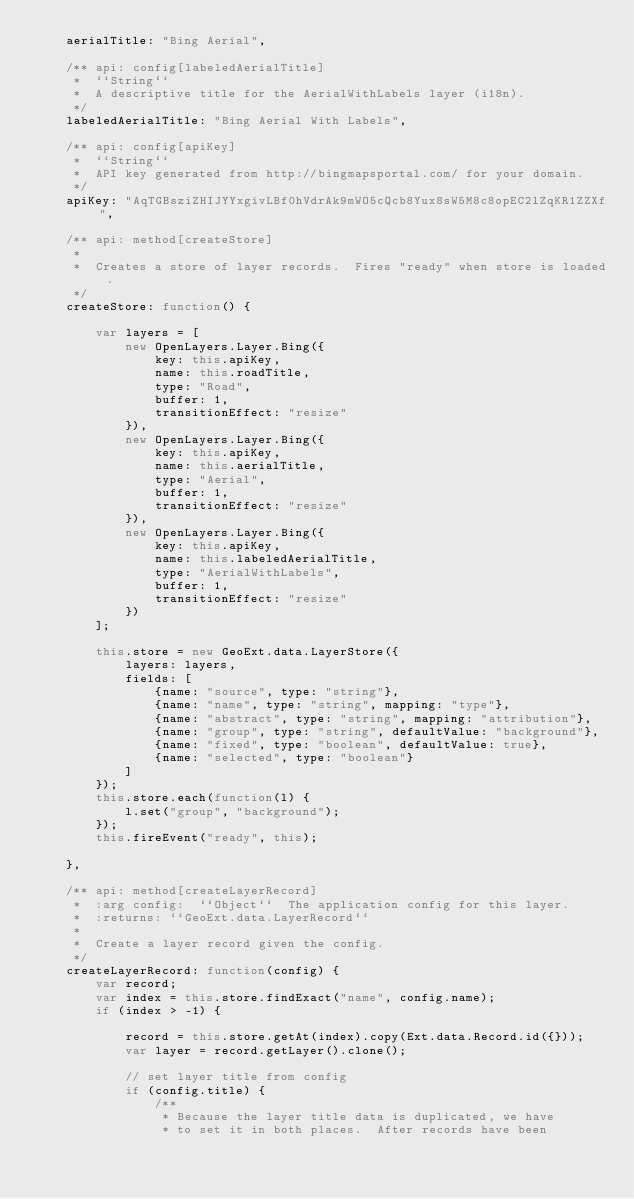Convert code to text. <code><loc_0><loc_0><loc_500><loc_500><_JavaScript_>    aerialTitle: "Bing Aerial",

    /** api: config[labeledAerialTitle]
     *  ``String``
     *  A descriptive title for the AerialWithLabels layer (i18n).
     */
    labeledAerialTitle: "Bing Aerial With Labels",
    
    /** api: config[apiKey]
     *  ``String``
     *  API key generated from http://bingmapsportal.com/ for your domain.
     */
    apiKey: "AqTGBsziZHIJYYxgivLBf0hVdrAk9mWO5cQcb8Yux8sW5M8c8opEC2lZqKR1ZZXf",
    
    /** api: method[createStore]
     *
     *  Creates a store of layer records.  Fires "ready" when store is loaded.
     */
    createStore: function() {
        
        var layers = [
            new OpenLayers.Layer.Bing({
                key: this.apiKey,
                name: this.roadTitle,
                type: "Road",
                buffer: 1,
                transitionEffect: "resize"
            }),
            new OpenLayers.Layer.Bing({
                key: this.apiKey,
                name: this.aerialTitle,
                type: "Aerial",
                buffer: 1,
                transitionEffect: "resize"
            }),
            new OpenLayers.Layer.Bing({
                key: this.apiKey,
                name: this.labeledAerialTitle,
                type: "AerialWithLabels",
                buffer: 1,
                transitionEffect: "resize"
            })
        ];
        
        this.store = new GeoExt.data.LayerStore({
            layers: layers,
            fields: [
                {name: "source", type: "string"},
                {name: "name", type: "string", mapping: "type"},
                {name: "abstract", type: "string", mapping: "attribution"},
                {name: "group", type: "string", defaultValue: "background"},
                {name: "fixed", type: "boolean", defaultValue: true},
                {name: "selected", type: "boolean"}
            ]
        });
        this.store.each(function(l) {
            l.set("group", "background");
        });
        this.fireEvent("ready", this);

    },
    
    /** api: method[createLayerRecord]
     *  :arg config:  ``Object``  The application config for this layer.
     *  :returns: ``GeoExt.data.LayerRecord``
     *
     *  Create a layer record given the config.
     */
    createLayerRecord: function(config) {
        var record;
        var index = this.store.findExact("name", config.name);
        if (index > -1) {

            record = this.store.getAt(index).copy(Ext.data.Record.id({}));
            var layer = record.getLayer().clone();
 
            // set layer title from config
            if (config.title) {
                /**
                 * Because the layer title data is duplicated, we have
                 * to set it in both places.  After records have been</code> 